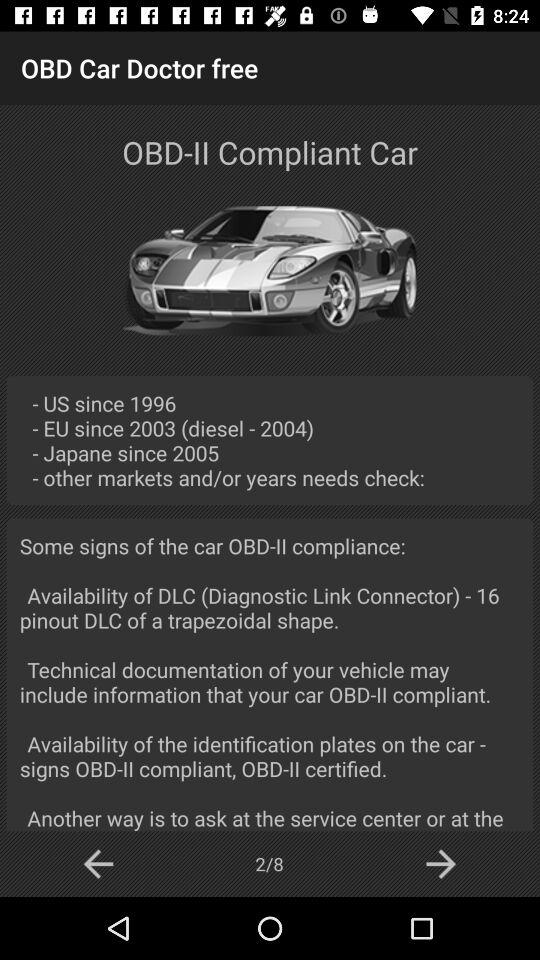Which market has the earliest OBD-II compliance requirement?
Answer the question using a single word or phrase. US 